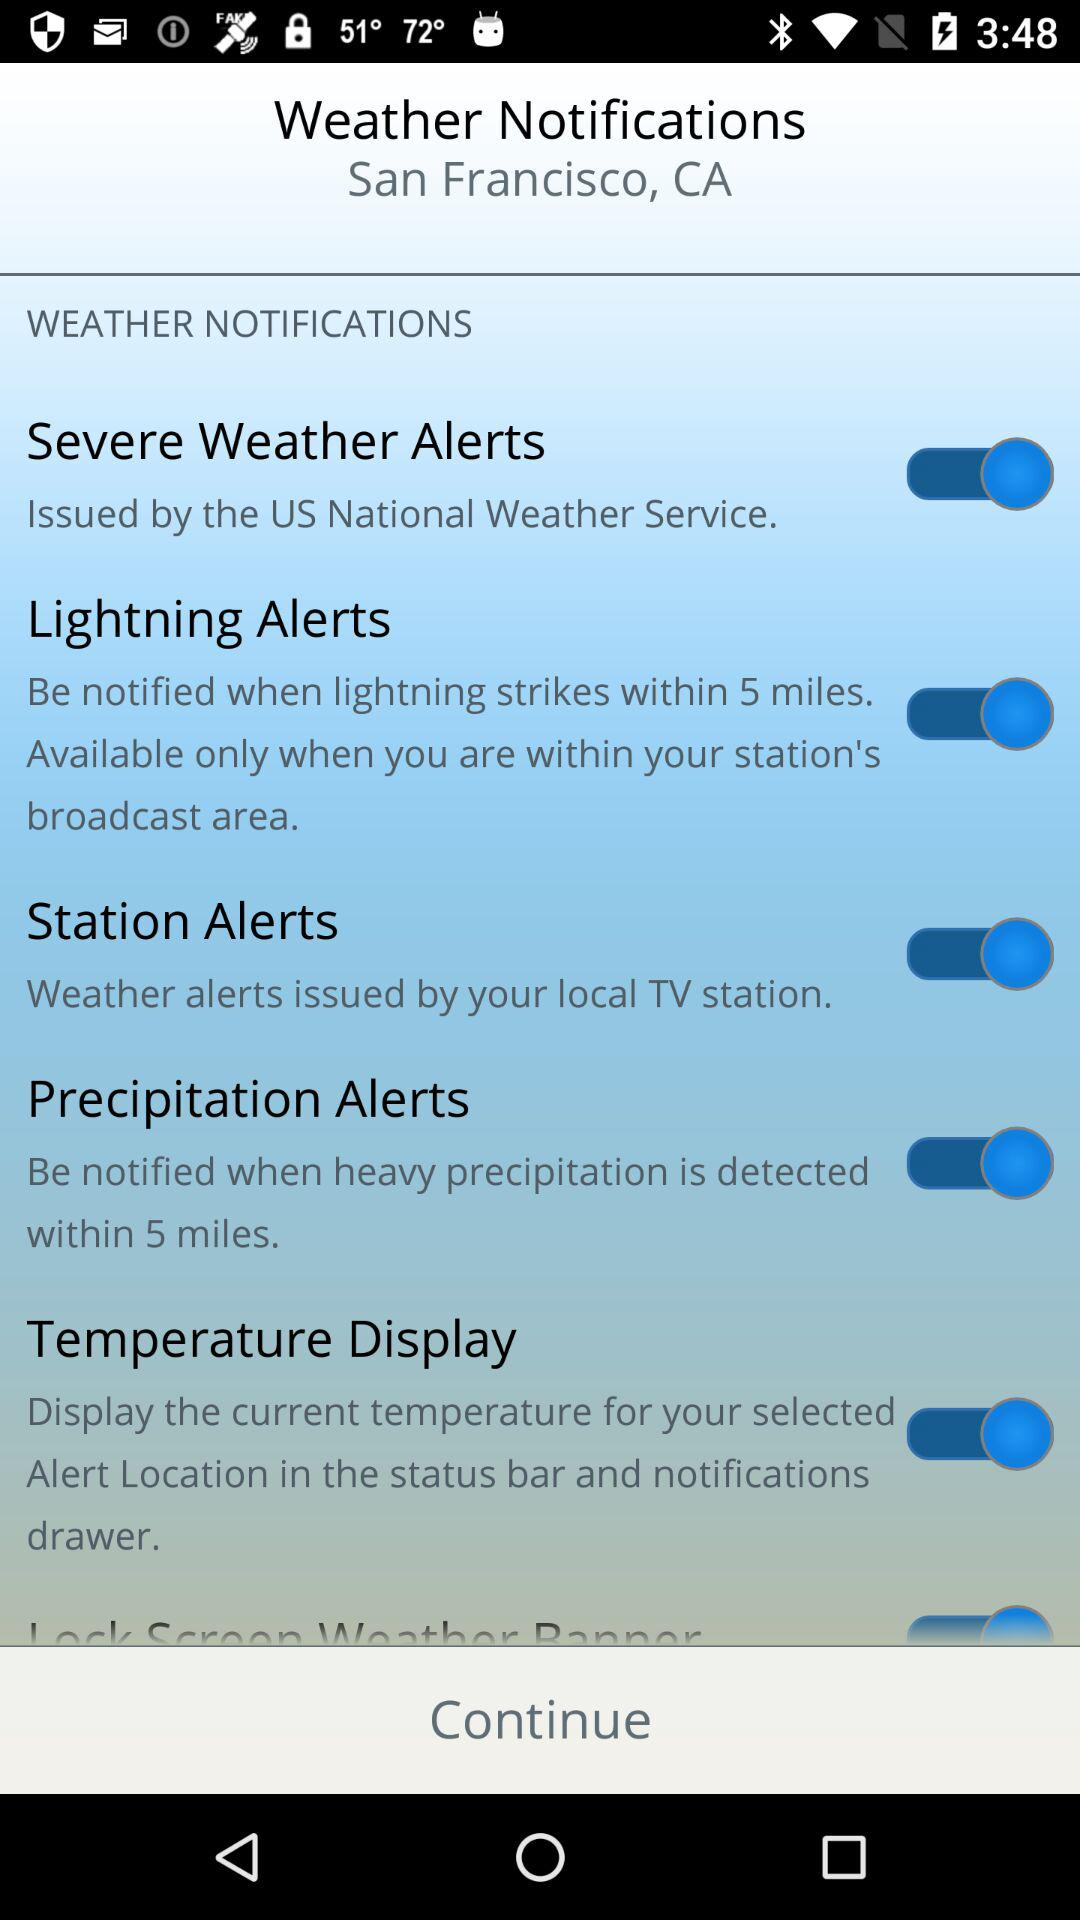What is the mentioned location? The mentioned location is San Francisco, CA. 